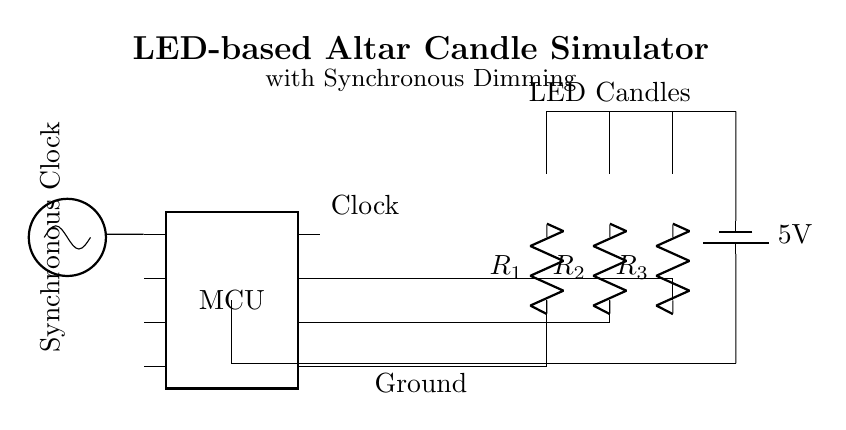What is the power supply voltage? The circuit indicates a 5V power supply, which is explicitly labeled next to the battery symbol.
Answer: 5V What type of components are used for dimming in this circuit? The circuit uses resistors in series with each LED to control the current flowing through them, thereby allowing for dimming.
Answer: Resistors How many LEDs are present in this circuit? The circuit diagram clearly shows three LED components connected in parallel.
Answer: Three What is the role of the clock in this circuit? The clock provides a synchronous signal to the microcontroller, which likely controls the timing for the dimming of the LEDs.
Answer: Synchronization What is the significance of the synchronous clock? The synchronous clock ensures that all LED dimming occurs simultaneously, maintaining a uniform lighting effect, which is crucial for visual consistency in an altar setting.
Answer: Uniform lighting Which part of the circuit is grounded? The circuit shows that the ground is connected to the negative terminal of the battery, indicating a common reference point for the entire circuit.
Answer: Battery negative terminal 